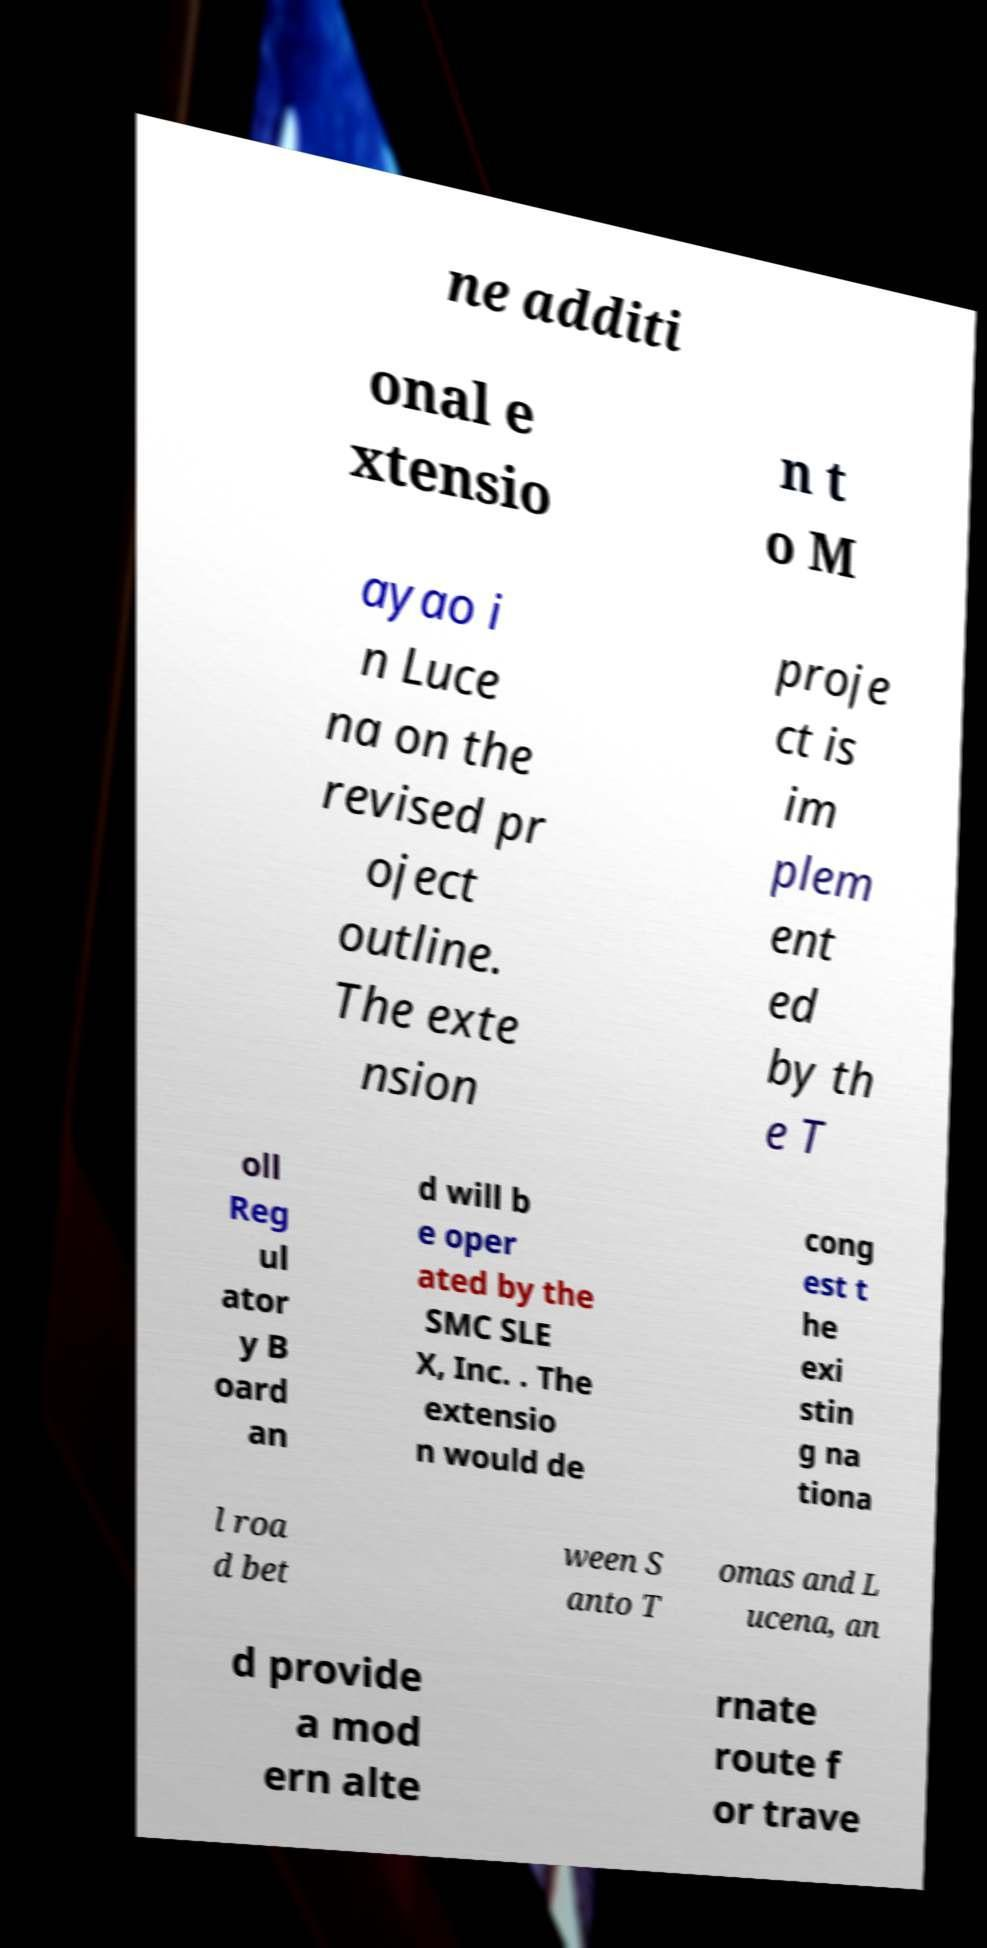For documentation purposes, I need the text within this image transcribed. Could you provide that? ne additi onal e xtensio n t o M ayao i n Luce na on the revised pr oject outline. The exte nsion proje ct is im plem ent ed by th e T oll Reg ul ator y B oard an d will b e oper ated by the SMC SLE X, Inc. . The extensio n would de cong est t he exi stin g na tiona l roa d bet ween S anto T omas and L ucena, an d provide a mod ern alte rnate route f or trave 